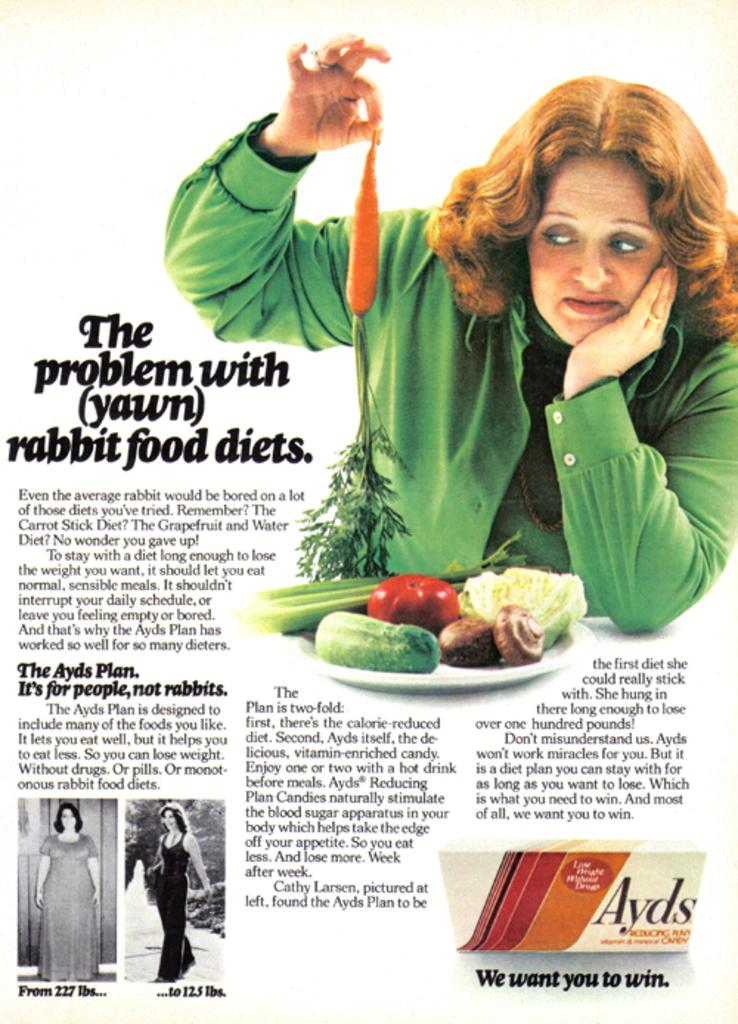<image>
Offer a succinct explanation of the picture presented. An ad for Ayds shows a woman with a carrot. 